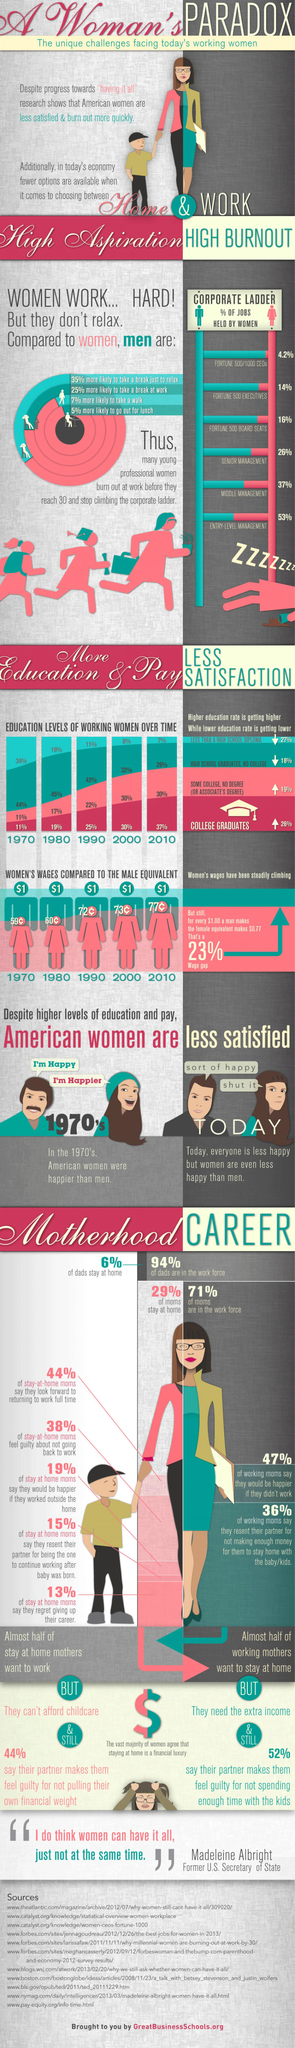Point out several critical features in this image. According to data, the average percentage increase in college graduates over the past five decades is 24.4%. In 2000, approximately 30% of women received an Associate degree or a college graduation. According to a recent survey, approximately 25% of men would take a recess from work. Senior Management holds the fourth highest percentage of men in the corporate ladder, with the least percentage of women. According to a recent study, it was found that 95% of women are less likely to go out for lunch. 